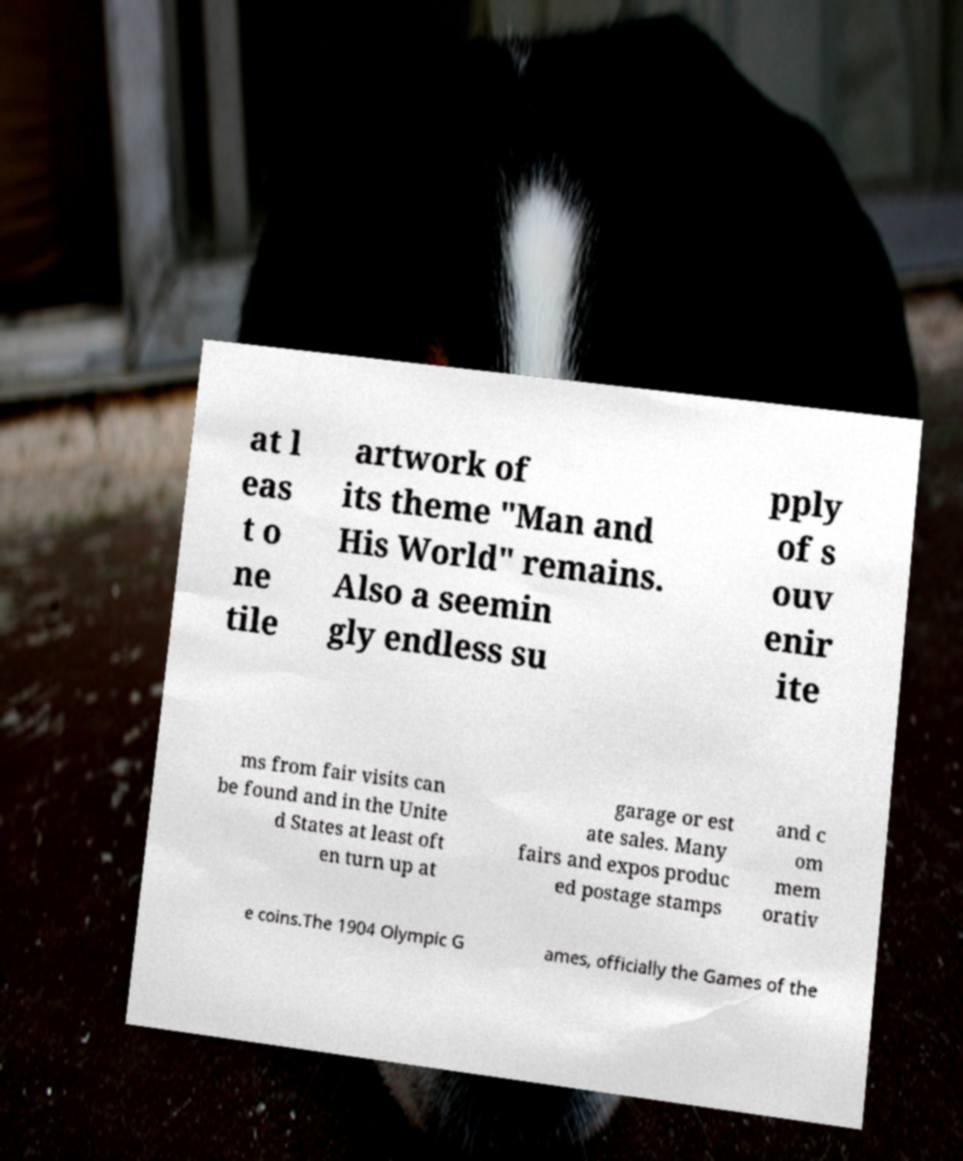There's text embedded in this image that I need extracted. Can you transcribe it verbatim? at l eas t o ne tile artwork of its theme "Man and His World" remains. Also a seemin gly endless su pply of s ouv enir ite ms from fair visits can be found and in the Unite d States at least oft en turn up at garage or est ate sales. Many fairs and expos produc ed postage stamps and c om mem orativ e coins.The 1904 Olympic G ames, officially the Games of the 